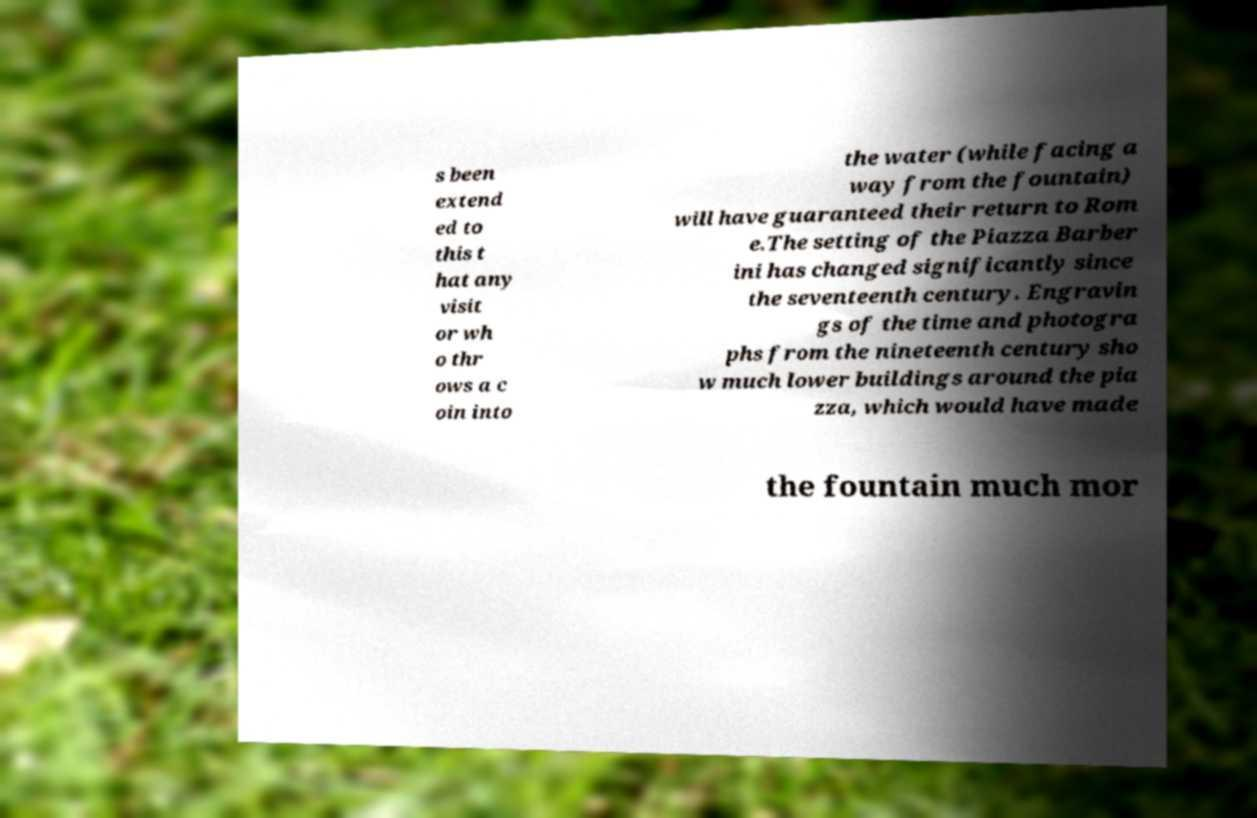Could you assist in decoding the text presented in this image and type it out clearly? s been extend ed to this t hat any visit or wh o thr ows a c oin into the water (while facing a way from the fountain) will have guaranteed their return to Rom e.The setting of the Piazza Barber ini has changed significantly since the seventeenth century. Engravin gs of the time and photogra phs from the nineteenth century sho w much lower buildings around the pia zza, which would have made the fountain much mor 